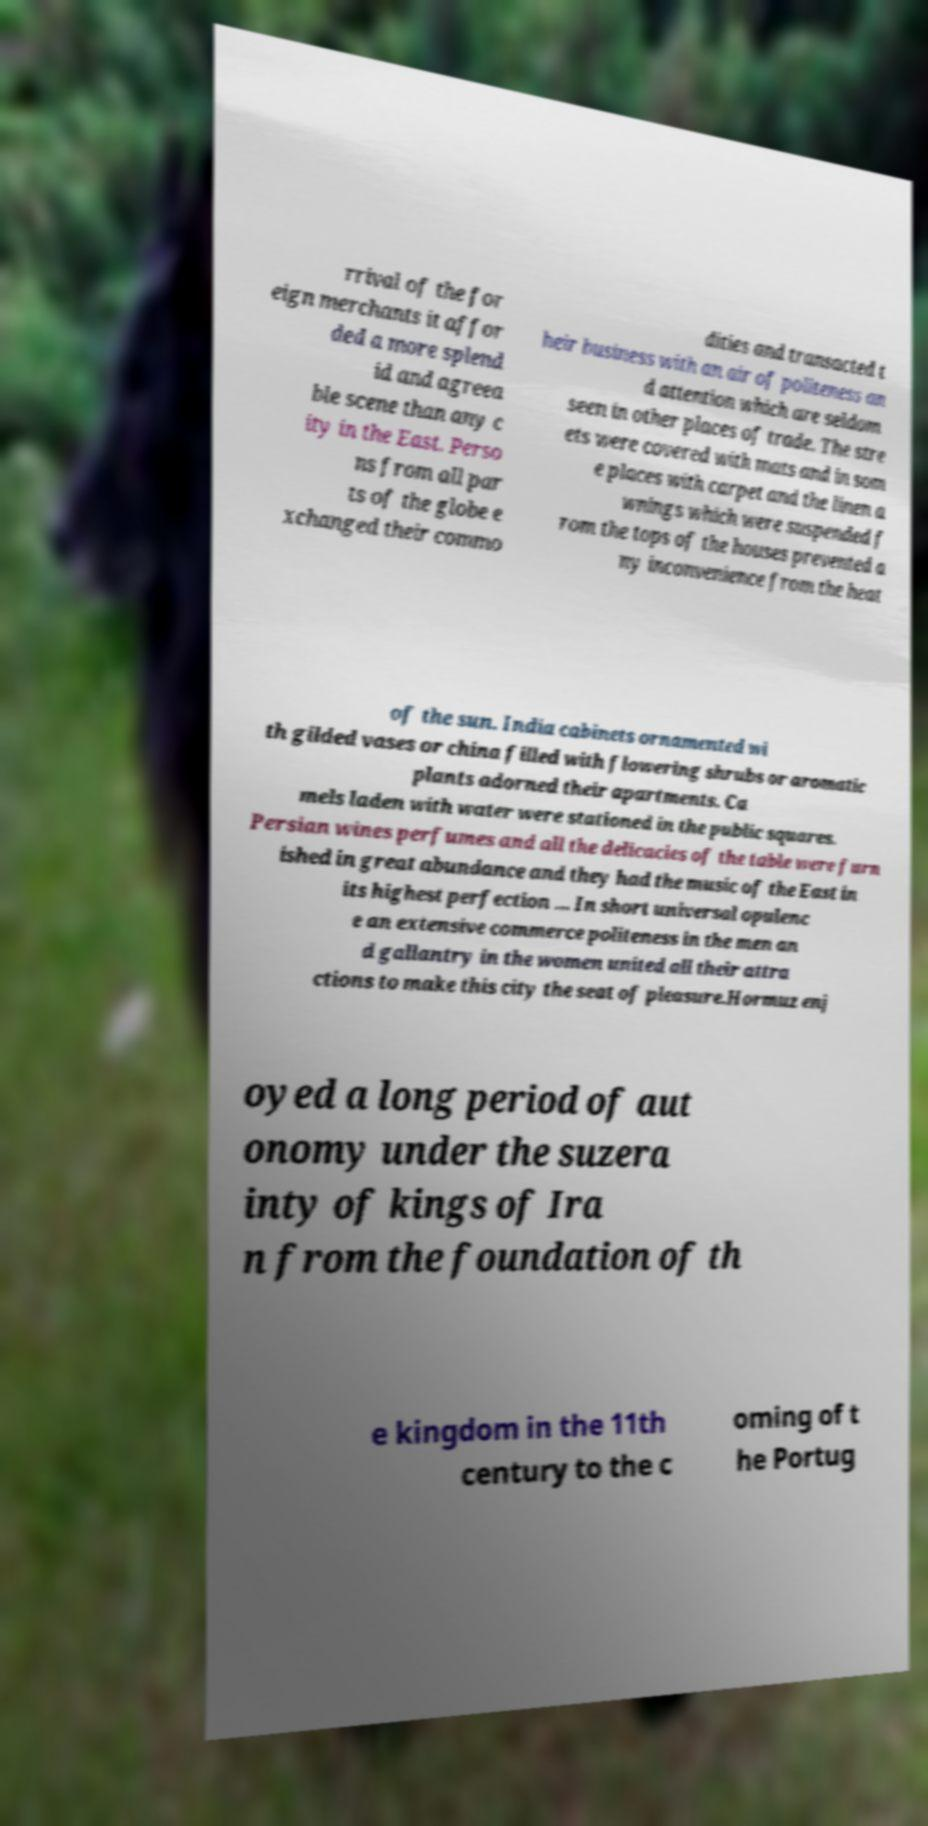Can you accurately transcribe the text from the provided image for me? rrival of the for eign merchants it affor ded a more splend id and agreea ble scene than any c ity in the East. Perso ns from all par ts of the globe e xchanged their commo dities and transacted t heir business with an air of politeness an d attention which are seldom seen in other places of trade. The stre ets were covered with mats and in som e places with carpet and the linen a wnings which were suspended f rom the tops of the houses prevented a ny inconvenience from the heat of the sun. India cabinets ornamented wi th gilded vases or china filled with flowering shrubs or aromatic plants adorned their apartments. Ca mels laden with water were stationed in the public squares. Persian wines perfumes and all the delicacies of the table were furn ished in great abundance and they had the music of the East in its highest perfection … In short universal opulenc e an extensive commerce politeness in the men an d gallantry in the women united all their attra ctions to make this city the seat of pleasure.Hormuz enj oyed a long period of aut onomy under the suzera inty of kings of Ira n from the foundation of th e kingdom in the 11th century to the c oming of t he Portug 